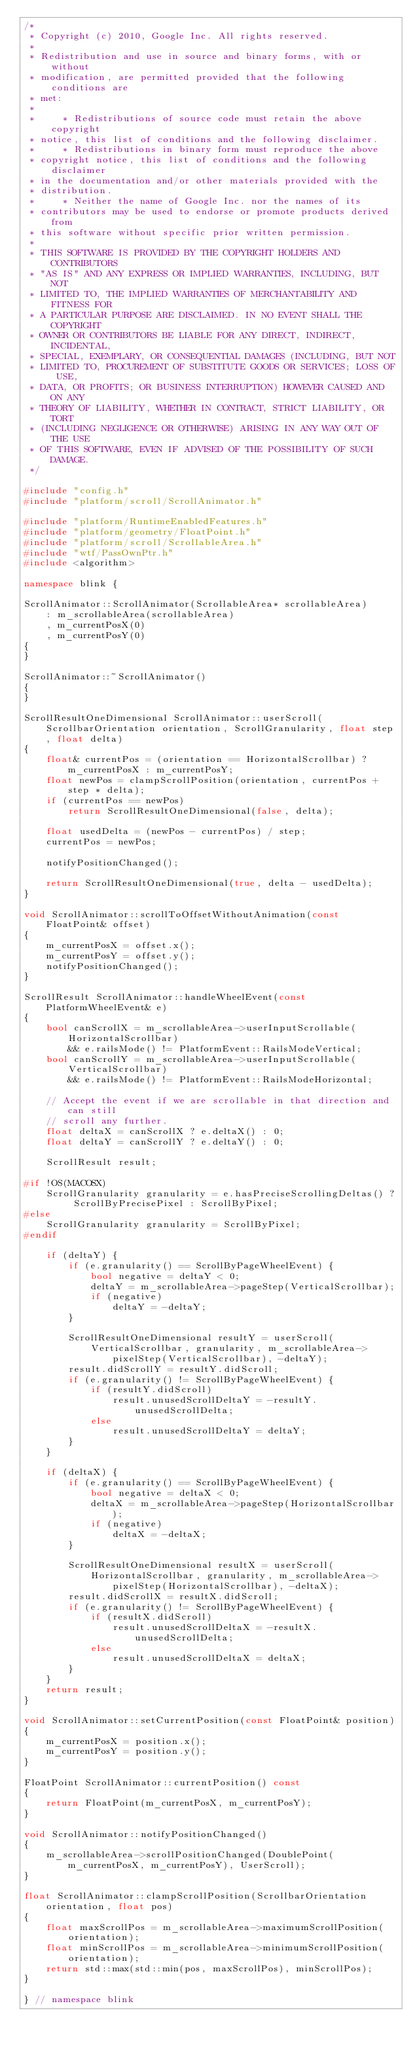<code> <loc_0><loc_0><loc_500><loc_500><_C++_>/*
 * Copyright (c) 2010, Google Inc. All rights reserved.
 *
 * Redistribution and use in source and binary forms, with or without
 * modification, are permitted provided that the following conditions are
 * met:
 *
 *     * Redistributions of source code must retain the above copyright
 * notice, this list of conditions and the following disclaimer.
 *     * Redistributions in binary form must reproduce the above
 * copyright notice, this list of conditions and the following disclaimer
 * in the documentation and/or other materials provided with the
 * distribution.
 *     * Neither the name of Google Inc. nor the names of its
 * contributors may be used to endorse or promote products derived from
 * this software without specific prior written permission.
 *
 * THIS SOFTWARE IS PROVIDED BY THE COPYRIGHT HOLDERS AND CONTRIBUTORS
 * "AS IS" AND ANY EXPRESS OR IMPLIED WARRANTIES, INCLUDING, BUT NOT
 * LIMITED TO, THE IMPLIED WARRANTIES OF MERCHANTABILITY AND FITNESS FOR
 * A PARTICULAR PURPOSE ARE DISCLAIMED. IN NO EVENT SHALL THE COPYRIGHT
 * OWNER OR CONTRIBUTORS BE LIABLE FOR ANY DIRECT, INDIRECT, INCIDENTAL,
 * SPECIAL, EXEMPLARY, OR CONSEQUENTIAL DAMAGES (INCLUDING, BUT NOT
 * LIMITED TO, PROCUREMENT OF SUBSTITUTE GOODS OR SERVICES; LOSS OF USE,
 * DATA, OR PROFITS; OR BUSINESS INTERRUPTION) HOWEVER CAUSED AND ON ANY
 * THEORY OF LIABILITY, WHETHER IN CONTRACT, STRICT LIABILITY, OR TORT
 * (INCLUDING NEGLIGENCE OR OTHERWISE) ARISING IN ANY WAY OUT OF THE USE
 * OF THIS SOFTWARE, EVEN IF ADVISED OF THE POSSIBILITY OF SUCH DAMAGE.
 */

#include "config.h"
#include "platform/scroll/ScrollAnimator.h"

#include "platform/RuntimeEnabledFeatures.h"
#include "platform/geometry/FloatPoint.h"
#include "platform/scroll/ScrollableArea.h"
#include "wtf/PassOwnPtr.h"
#include <algorithm>

namespace blink {

ScrollAnimator::ScrollAnimator(ScrollableArea* scrollableArea)
    : m_scrollableArea(scrollableArea)
    , m_currentPosX(0)
    , m_currentPosY(0)
{
}

ScrollAnimator::~ScrollAnimator()
{
}

ScrollResultOneDimensional ScrollAnimator::userScroll(ScrollbarOrientation orientation, ScrollGranularity, float step, float delta)
{
    float& currentPos = (orientation == HorizontalScrollbar) ? m_currentPosX : m_currentPosY;
    float newPos = clampScrollPosition(orientation, currentPos + step * delta);
    if (currentPos == newPos)
        return ScrollResultOneDimensional(false, delta);

    float usedDelta = (newPos - currentPos) / step;
    currentPos = newPos;

    notifyPositionChanged();

    return ScrollResultOneDimensional(true, delta - usedDelta);
}

void ScrollAnimator::scrollToOffsetWithoutAnimation(const FloatPoint& offset)
{
    m_currentPosX = offset.x();
    m_currentPosY = offset.y();
    notifyPositionChanged();
}

ScrollResult ScrollAnimator::handleWheelEvent(const PlatformWheelEvent& e)
{
    bool canScrollX = m_scrollableArea->userInputScrollable(HorizontalScrollbar)
        && e.railsMode() != PlatformEvent::RailsModeVertical;
    bool canScrollY = m_scrollableArea->userInputScrollable(VerticalScrollbar)
        && e.railsMode() != PlatformEvent::RailsModeHorizontal;

    // Accept the event if we are scrollable in that direction and can still
    // scroll any further.
    float deltaX = canScrollX ? e.deltaX() : 0;
    float deltaY = canScrollY ? e.deltaY() : 0;

    ScrollResult result;

#if !OS(MACOSX)
    ScrollGranularity granularity = e.hasPreciseScrollingDeltas() ? ScrollByPrecisePixel : ScrollByPixel;
#else
    ScrollGranularity granularity = ScrollByPixel;
#endif

    if (deltaY) {
        if (e.granularity() == ScrollByPageWheelEvent) {
            bool negative = deltaY < 0;
            deltaY = m_scrollableArea->pageStep(VerticalScrollbar);
            if (negative)
                deltaY = -deltaY;
        }

        ScrollResultOneDimensional resultY = userScroll(
            VerticalScrollbar, granularity, m_scrollableArea->pixelStep(VerticalScrollbar), -deltaY);
        result.didScrollY = resultY.didScroll;
        if (e.granularity() != ScrollByPageWheelEvent) {
            if (resultY.didScroll)
                result.unusedScrollDeltaY = -resultY.unusedScrollDelta;
            else
                result.unusedScrollDeltaY = deltaY;
        }
    }

    if (deltaX) {
        if (e.granularity() == ScrollByPageWheelEvent) {
            bool negative = deltaX < 0;
            deltaX = m_scrollableArea->pageStep(HorizontalScrollbar);
            if (negative)
                deltaX = -deltaX;
        }

        ScrollResultOneDimensional resultX = userScroll(
            HorizontalScrollbar, granularity, m_scrollableArea->pixelStep(HorizontalScrollbar), -deltaX);
        result.didScrollX = resultX.didScroll;
        if (e.granularity() != ScrollByPageWheelEvent) {
            if (resultX.didScroll)
                result.unusedScrollDeltaX = -resultX.unusedScrollDelta;
            else
                result.unusedScrollDeltaX = deltaX;
        }
    }
    return result;
}

void ScrollAnimator::setCurrentPosition(const FloatPoint& position)
{
    m_currentPosX = position.x();
    m_currentPosY = position.y();
}

FloatPoint ScrollAnimator::currentPosition() const
{
    return FloatPoint(m_currentPosX, m_currentPosY);
}

void ScrollAnimator::notifyPositionChanged()
{
    m_scrollableArea->scrollPositionChanged(DoublePoint(m_currentPosX, m_currentPosY), UserScroll);
}

float ScrollAnimator::clampScrollPosition(ScrollbarOrientation orientation, float pos)
{
    float maxScrollPos = m_scrollableArea->maximumScrollPosition(orientation);
    float minScrollPos = m_scrollableArea->minimumScrollPosition(orientation);
    return std::max(std::min(pos, maxScrollPos), minScrollPos);
}

} // namespace blink
</code> 